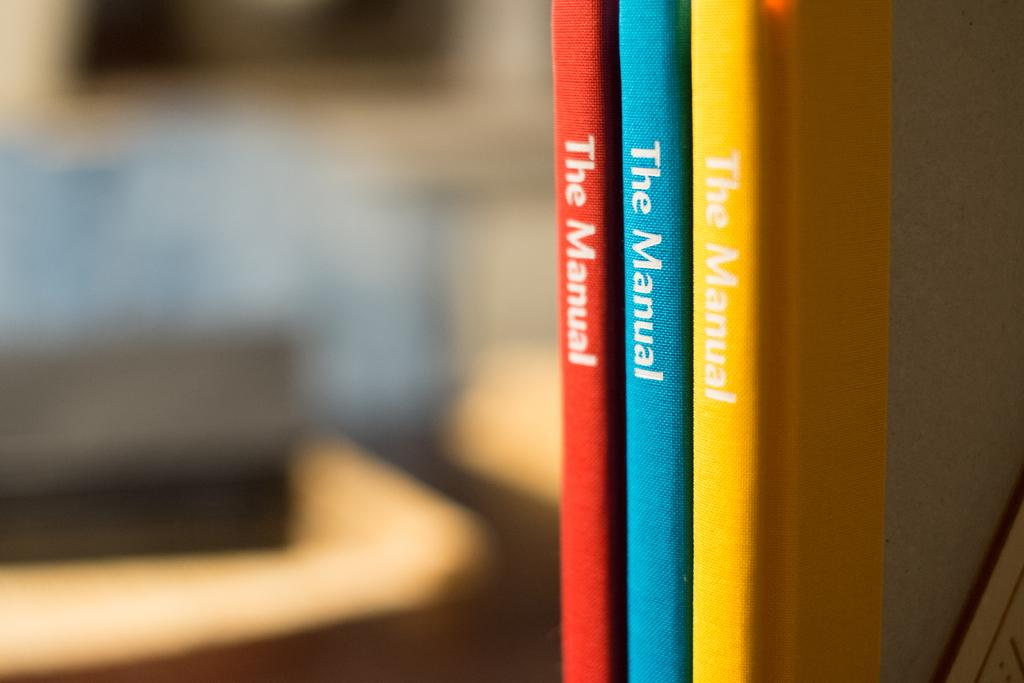Provide a one-sentence caption for the provided image. Three thin books are titled The Manual and one is red, one is blue and one is yellow in color. 